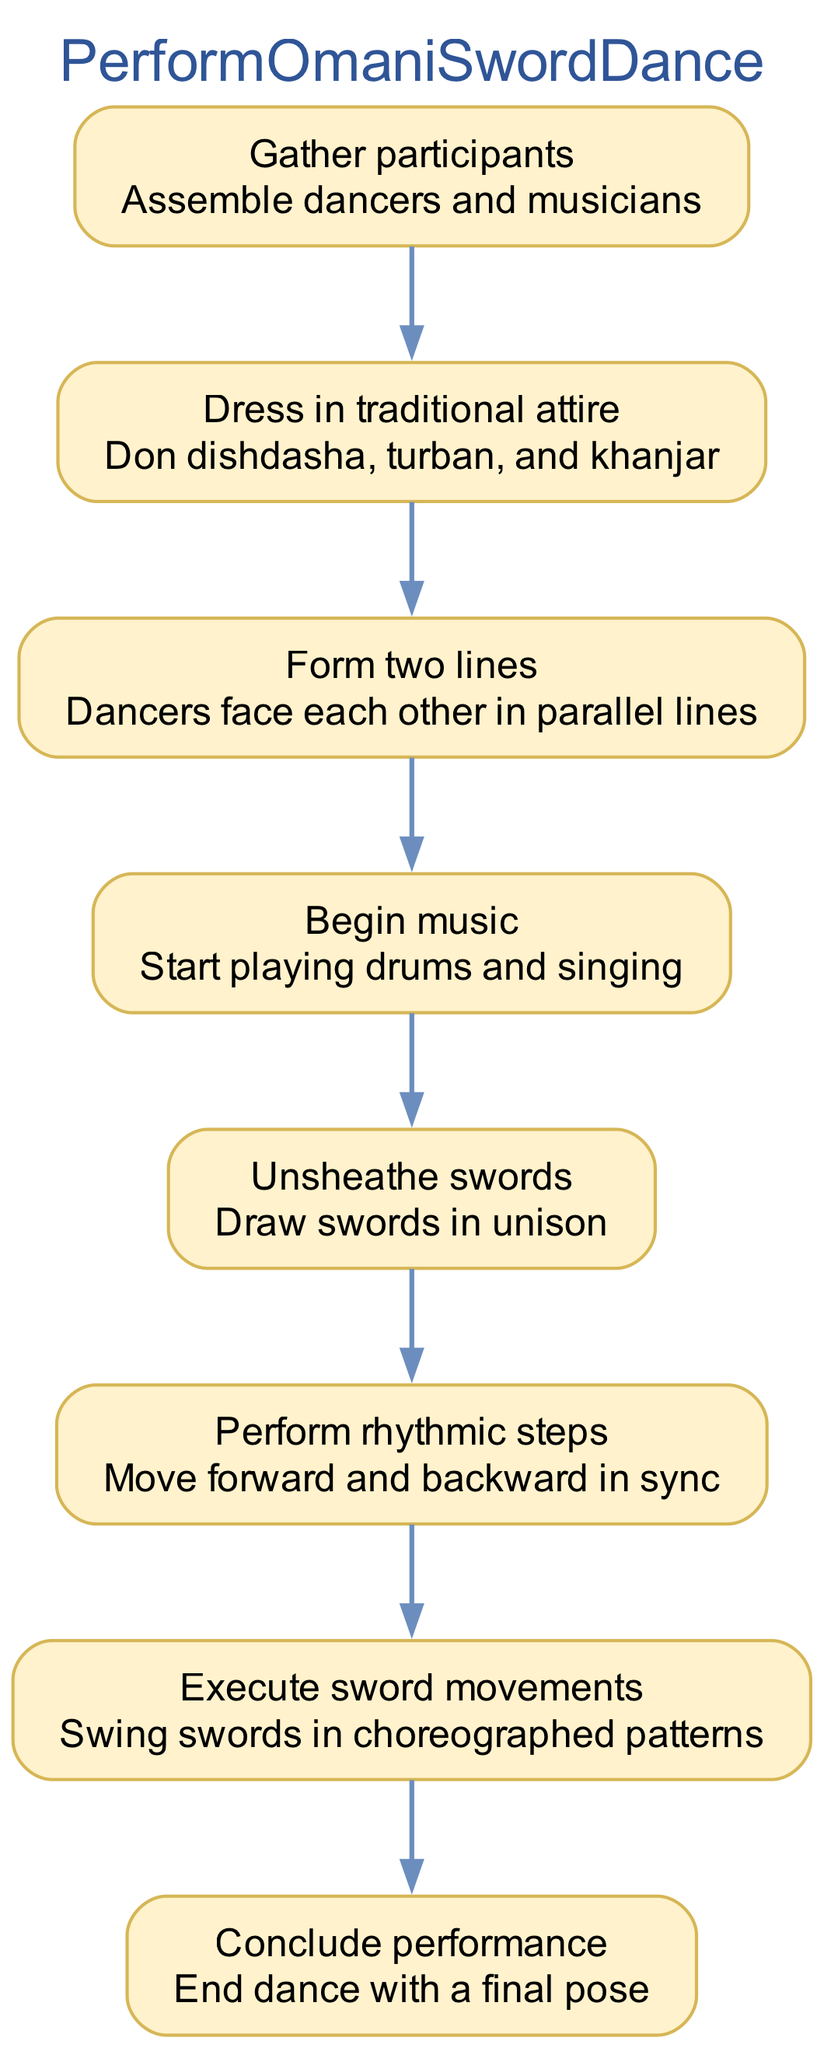What is the first step in performing the Omani sword dance? The first step is "Gather participants," which involves assembling dancers and musicians. This is clearly stated as the first action in the flow chart.
Answer: Gather participants How many total steps are there in this diagram? By counting the steps listed in the flow chart, we find there are 8 distinct steps from gathering participants to concluding the performance.
Answer: 8 What action follows "Dress in traditional attire"? According to the flow chart, the action that follows is "Form two lines." This shows the correct sequence of actions needed after dressing.
Answer: Form two lines What is the description of the step "Execute sword movements"? The description given is "Swing swords in choreographed patterns," indicating what the dancers need to focus on during this step.
Answer: Swing swords in choreographed patterns Which step includes the action of drawing swords? The step that includes this action is "Unsheathe swords," as indicated in the diagram.
Answer: Unsheathe swords How are the dancers positioned in the "Form two lines" step? The dancers are positioned to "face each other in parallel lines," which emphasizes the arrangement necessary for the next actions.
Answer: Face each other in parallel lines What is the final step in the Omani sword dance? The final step listed is "Conclude performance," which specifies how the dance should end.
Answer: Conclude performance What action must take place after "Begin music"? Following "Begin music," the next action is "Unsheathe swords," signifying the transition from preparation to action in the dance process.
Answer: Unsheathe swords Which two actions are directly connected in the diagram? The actions "Form two lines" and "Begin music" are directly connected, with "Begin music" leading into the next action in the sequence immediately after "Form two lines."
Answer: Form two lines and Begin music 